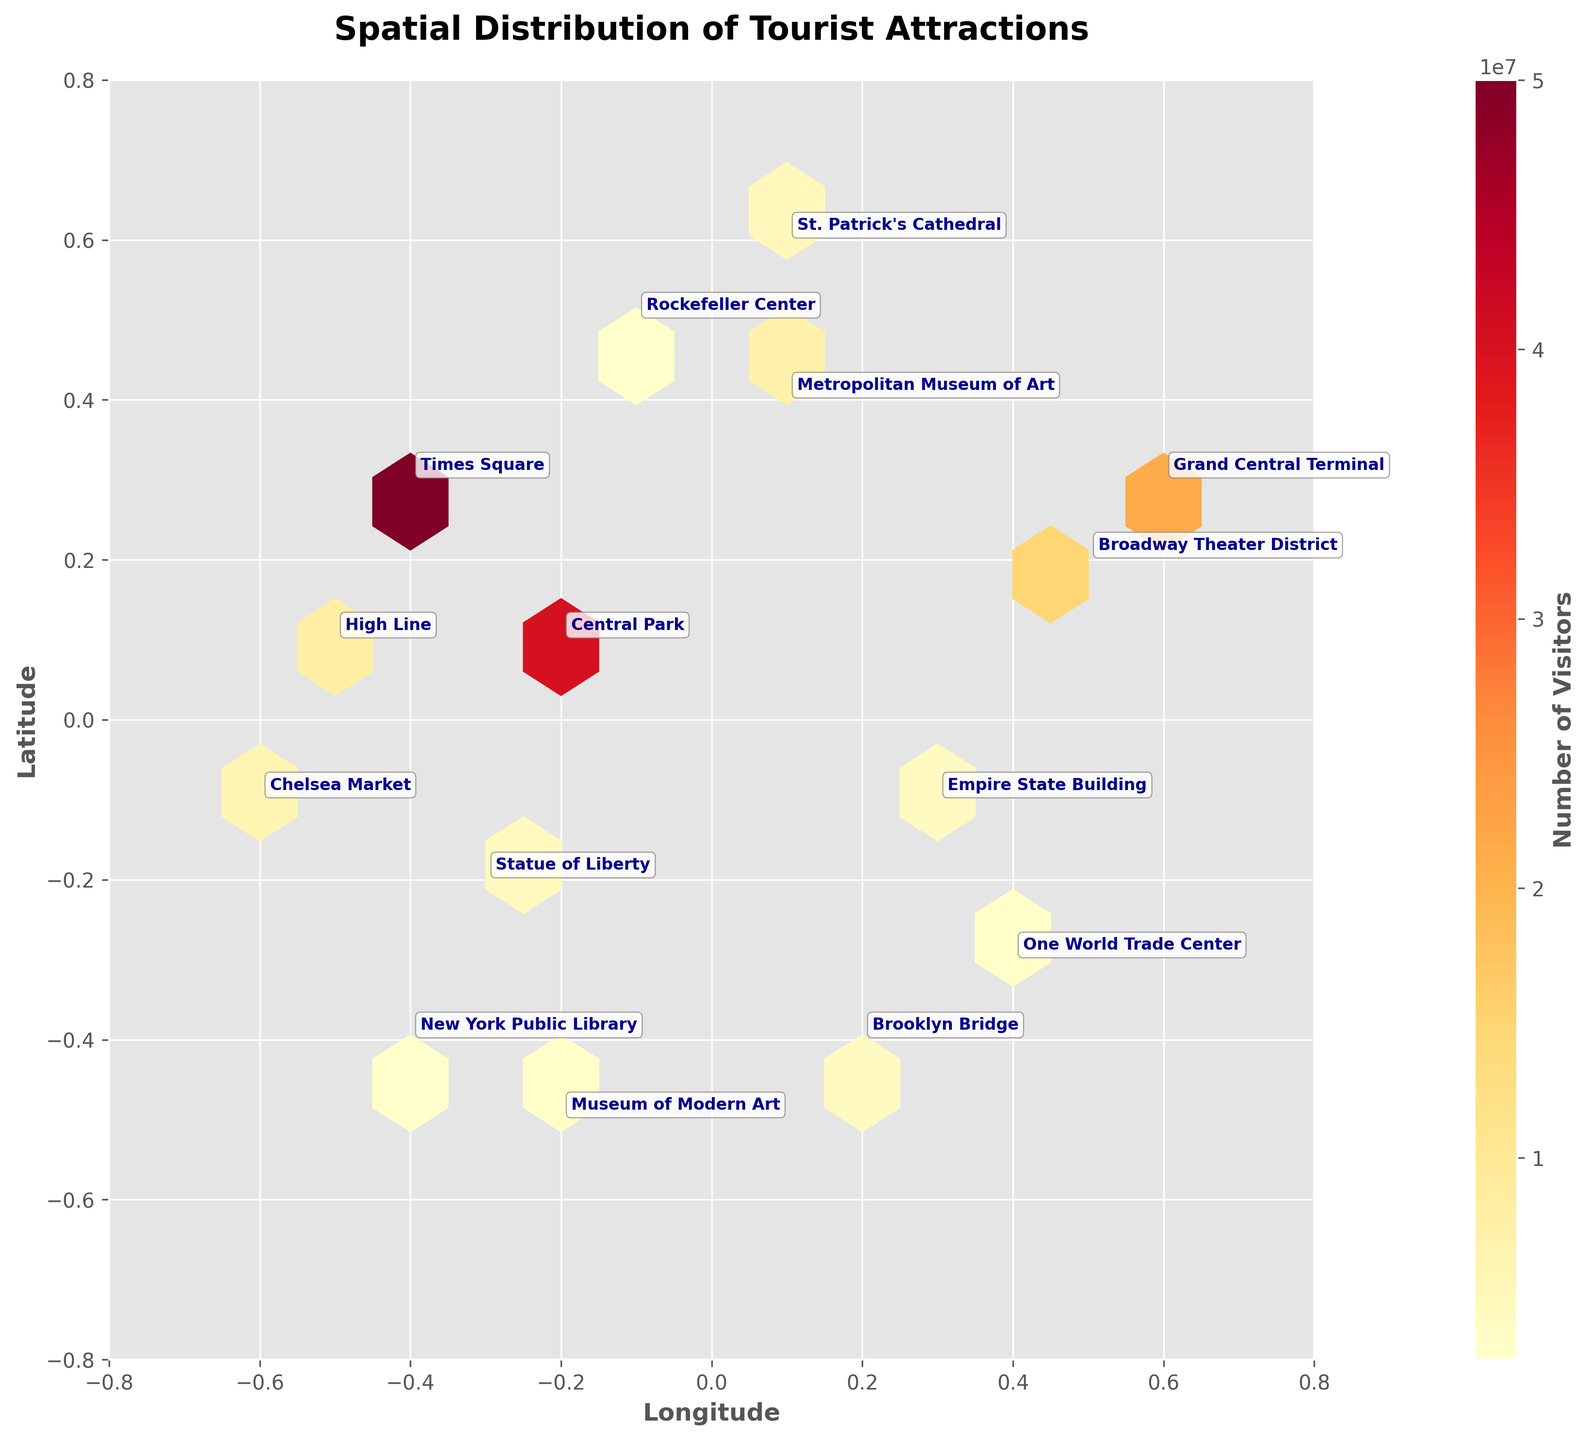What is the title of the plot? The title of the plot is prominently displayed at the top of the figure.
Answer: Spatial Distribution of Tourist Attractions How many visitor attractions are shown on the plot? By counting the annotations, you can see there are 15 attractions represented on the plot.
Answer: 15 Which attraction has the highest visitor count? The color gradient and annotation indicate that Times Square has the highest visitor count.
Answer: Times Square Which attractions have a visitor count of less than 3 million? Look for the annotations with lower visitor counts and cross-reference their positions with less intense hexbin colors. Rockefeller Center, One World Trade Center, New York Public Library, and Museum of Modern Art are below 3 million.
Answer: Rockefeller Center, One World Trade Center, New York Public Library, Museum of Modern Art Where is the highest density of attractions located on the plot? The densest area can be identified by the concentration of hexagons around the zero point on the plot. The area near the center shows the highest density.
Answer: Near the center Compare the visitor counts of Central Park and Times Square. Which one is higher and by how much? Central Park has 40 million visitors, while Times Square has 50 million visitors. Subtract 40 million from 50 million.
Answer: Times Square by 10 million What's the average visitor count of attractions located in the top right quadrant of the plot? Identify the attractions in the top right quadrant: Broadway Theater District, Grand Central Terminal, St. Patrick's Cathedral, and Metropolitan Museum of Art. Sum their visitor counts (14.8M + 21.6M + 5M + 7M) and divide by 4.
Answer: 12.1 million Which attraction is located furthest to the left on the plot? By looking at the x-axis where the lowest x value is, Chelsea Market is located furthest to the left.
Answer: Chelsea Market Compare the number of attractions with visitor counts more than 10 million and those with less than 10 million. How many are there in each category? Attractions with more than 10 million are Central Park, Times Square, and Grand Central Terminal (3). Counting the rest, there are 12 attractions with less than 10 million visitors.
Answer: More than 10 million: 3, Less than 10 million: 12 What is the color of the hexagons associated with the highest visitor counts? The color bar indicates that the highest visitor counts correspond to the darkest red hexagons.
Answer: Dark red 